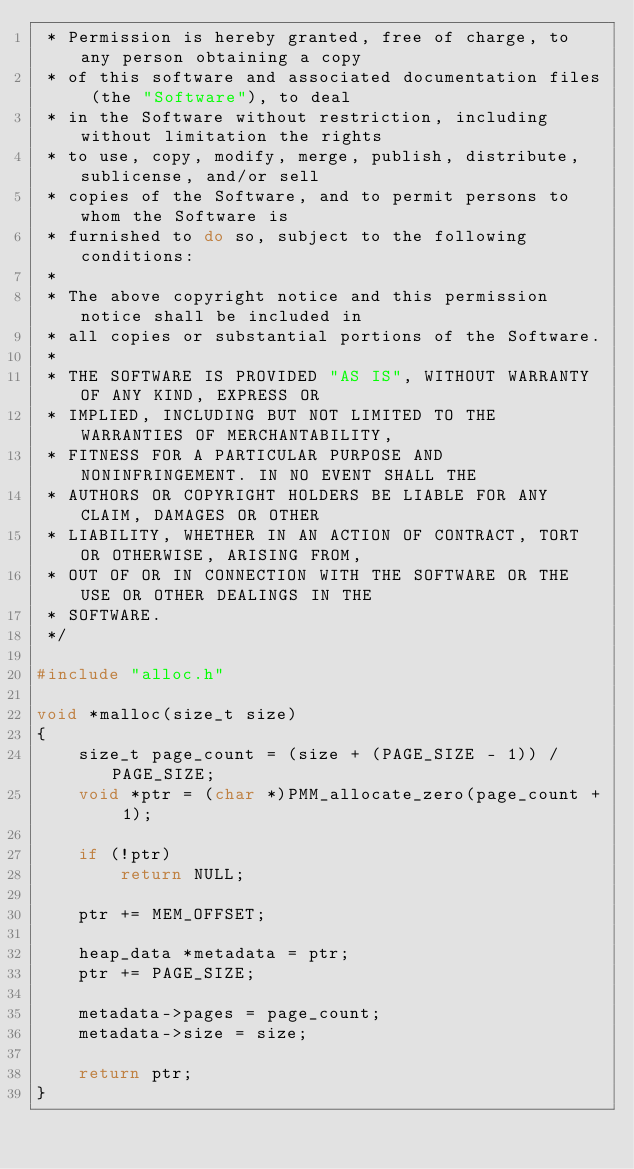Convert code to text. <code><loc_0><loc_0><loc_500><loc_500><_C_> * Permission is hereby granted, free of charge, to any person obtaining a copy
 * of this software and associated documentation files (the "Software"), to deal
 * in the Software without restriction, including without limitation the rights
 * to use, copy, modify, merge, publish, distribute, sublicense, and/or sell
 * copies of the Software, and to permit persons to whom the Software is
 * furnished to do so, subject to the following conditions:
 *
 * The above copyright notice and this permission notice shall be included in
 * all copies or substantial portions of the Software.
 *
 * THE SOFTWARE IS PROVIDED "AS IS", WITHOUT WARRANTY OF ANY KIND, EXPRESS OR
 * IMPLIED, INCLUDING BUT NOT LIMITED TO THE WARRANTIES OF MERCHANTABILITY,
 * FITNESS FOR A PARTICULAR PURPOSE AND NONINFRINGEMENT. IN NO EVENT SHALL THE
 * AUTHORS OR COPYRIGHT HOLDERS BE LIABLE FOR ANY CLAIM, DAMAGES OR OTHER
 * LIABILITY, WHETHER IN AN ACTION OF CONTRACT, TORT OR OTHERWISE, ARISING FROM,
 * OUT OF OR IN CONNECTION WITH THE SOFTWARE OR THE USE OR OTHER DEALINGS IN THE
 * SOFTWARE.
 */

#include "alloc.h"

void *malloc(size_t size)
{
    size_t page_count = (size + (PAGE_SIZE - 1)) / PAGE_SIZE;
    void *ptr = (char *)PMM_allocate_zero(page_count + 1);

    if (!ptr)
        return NULL;

    ptr += MEM_OFFSET;

    heap_data *metadata = ptr;
    ptr += PAGE_SIZE;

    metadata->pages = page_count;
    metadata->size = size;

    return ptr;
}
</code> 